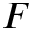Convert formula to latex. <formula><loc_0><loc_0><loc_500><loc_500>F</formula> 